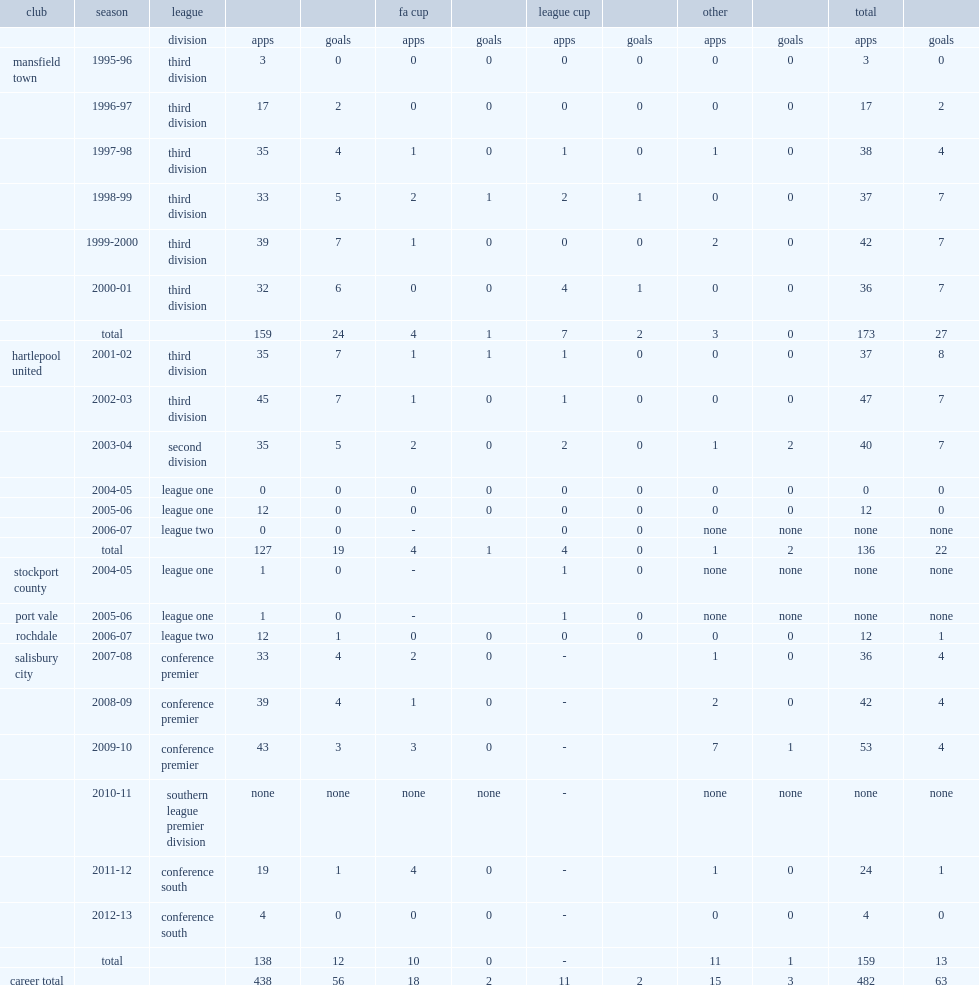How many appearances did darrell clarke rack up for hartlepool united in six years from 2001? 127.0. 